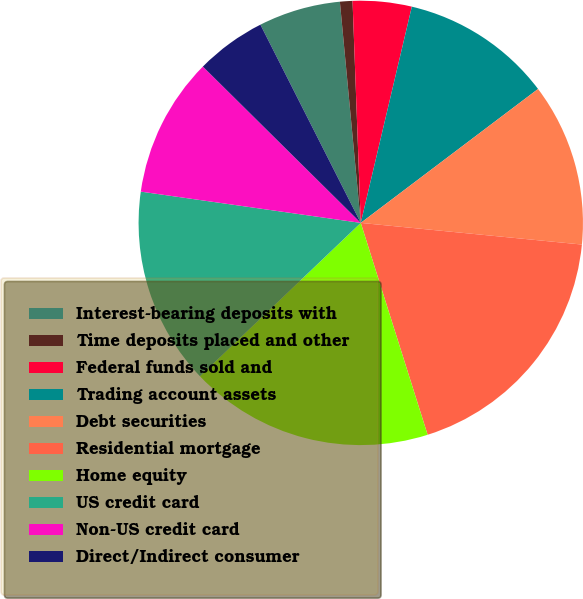<chart> <loc_0><loc_0><loc_500><loc_500><pie_chart><fcel>Interest-bearing deposits with<fcel>Time deposits placed and other<fcel>Federal funds sold and<fcel>Trading account assets<fcel>Debt securities<fcel>Residential mortgage<fcel>Home equity<fcel>US credit card<fcel>Non-US credit card<fcel>Direct/Indirect consumer<nl><fcel>5.96%<fcel>0.91%<fcel>4.28%<fcel>11.01%<fcel>11.85%<fcel>18.58%<fcel>17.74%<fcel>14.37%<fcel>10.17%<fcel>5.12%<nl></chart> 